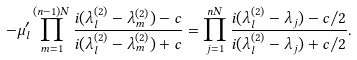Convert formula to latex. <formula><loc_0><loc_0><loc_500><loc_500>- \mu ^ { \prime } _ { l } \prod _ { m = 1 } ^ { ( n - 1 ) N } \frac { i ( \lambda ^ { ( 2 ) } _ { l } - \lambda ^ { ( 2 ) } _ { m } ) - c } { i ( \lambda ^ { ( 2 ) } _ { l } - \lambda ^ { ( 2 ) } _ { m } ) + c } = \prod _ { j = 1 } ^ { n N } \frac { i ( \lambda ^ { ( 2 ) } _ { l } - \lambda _ { j } ) - c / 2 } { i ( \lambda ^ { ( 2 ) } _ { l } - \lambda _ { j } ) + c / 2 } .</formula> 